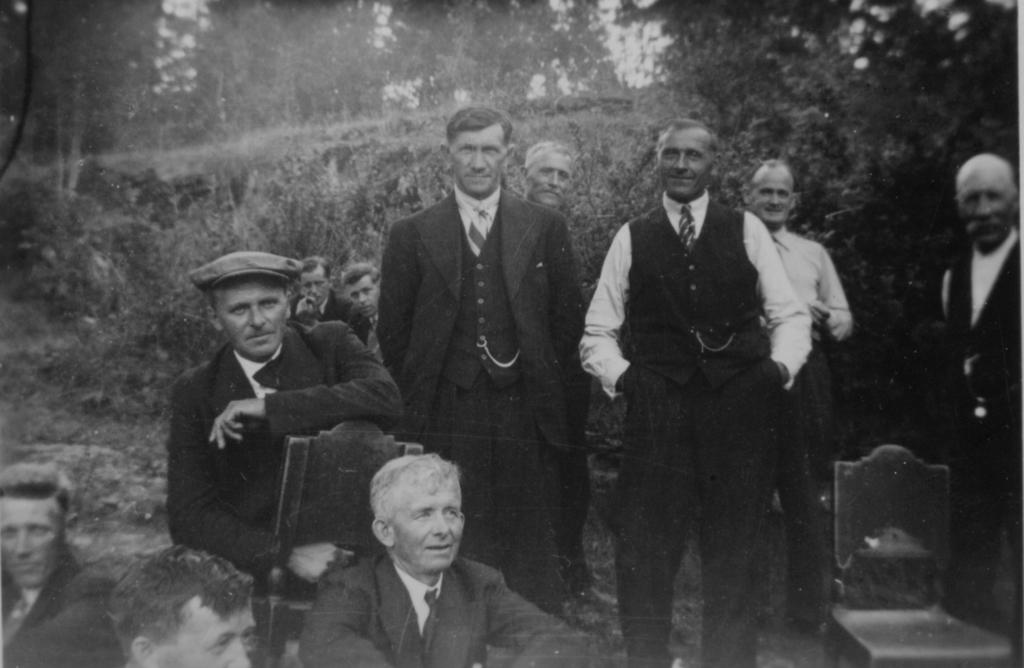What are the people in the image doing? Some people are standing, and others are sitting on chairs in the image. What can be seen in the background of the image? Trees are visible in the background of the image. What is the color scheme of the image? The image is in black and white. Can you tell me how many ducks are sitting on the chairs in the image? There are no ducks present in the image; it features people standing and sitting on chairs. What type of touch can be seen between the people in the image? There is no specific touch visible between the people in the image; they are simply standing or sitting. 